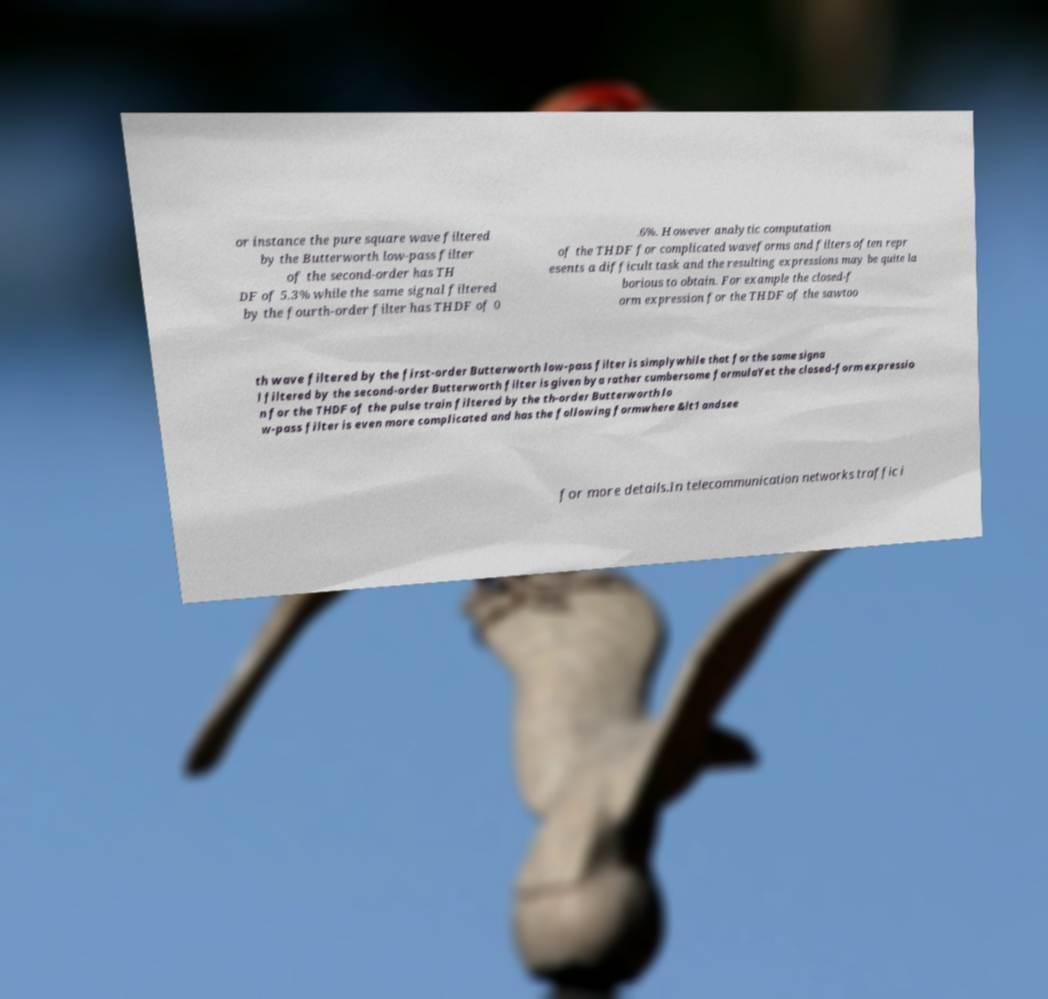Could you assist in decoding the text presented in this image and type it out clearly? or instance the pure square wave filtered by the Butterworth low-pass filter of the second-order has TH DF of 5.3% while the same signal filtered by the fourth-order filter has THDF of 0 .6%. However analytic computation of the THDF for complicated waveforms and filters often repr esents a difficult task and the resulting expressions may be quite la borious to obtain. For example the closed-f orm expression for the THDF of the sawtoo th wave filtered by the first-order Butterworth low-pass filter is simplywhile that for the same signa l filtered by the second-order Butterworth filter is given bya rather cumbersome formulaYet the closed-form expressio n for the THDF of the pulse train filtered by the th-order Butterworth lo w-pass filter is even more complicated and has the following formwhere &lt1 andsee for more details.In telecommunication networks traffic i 